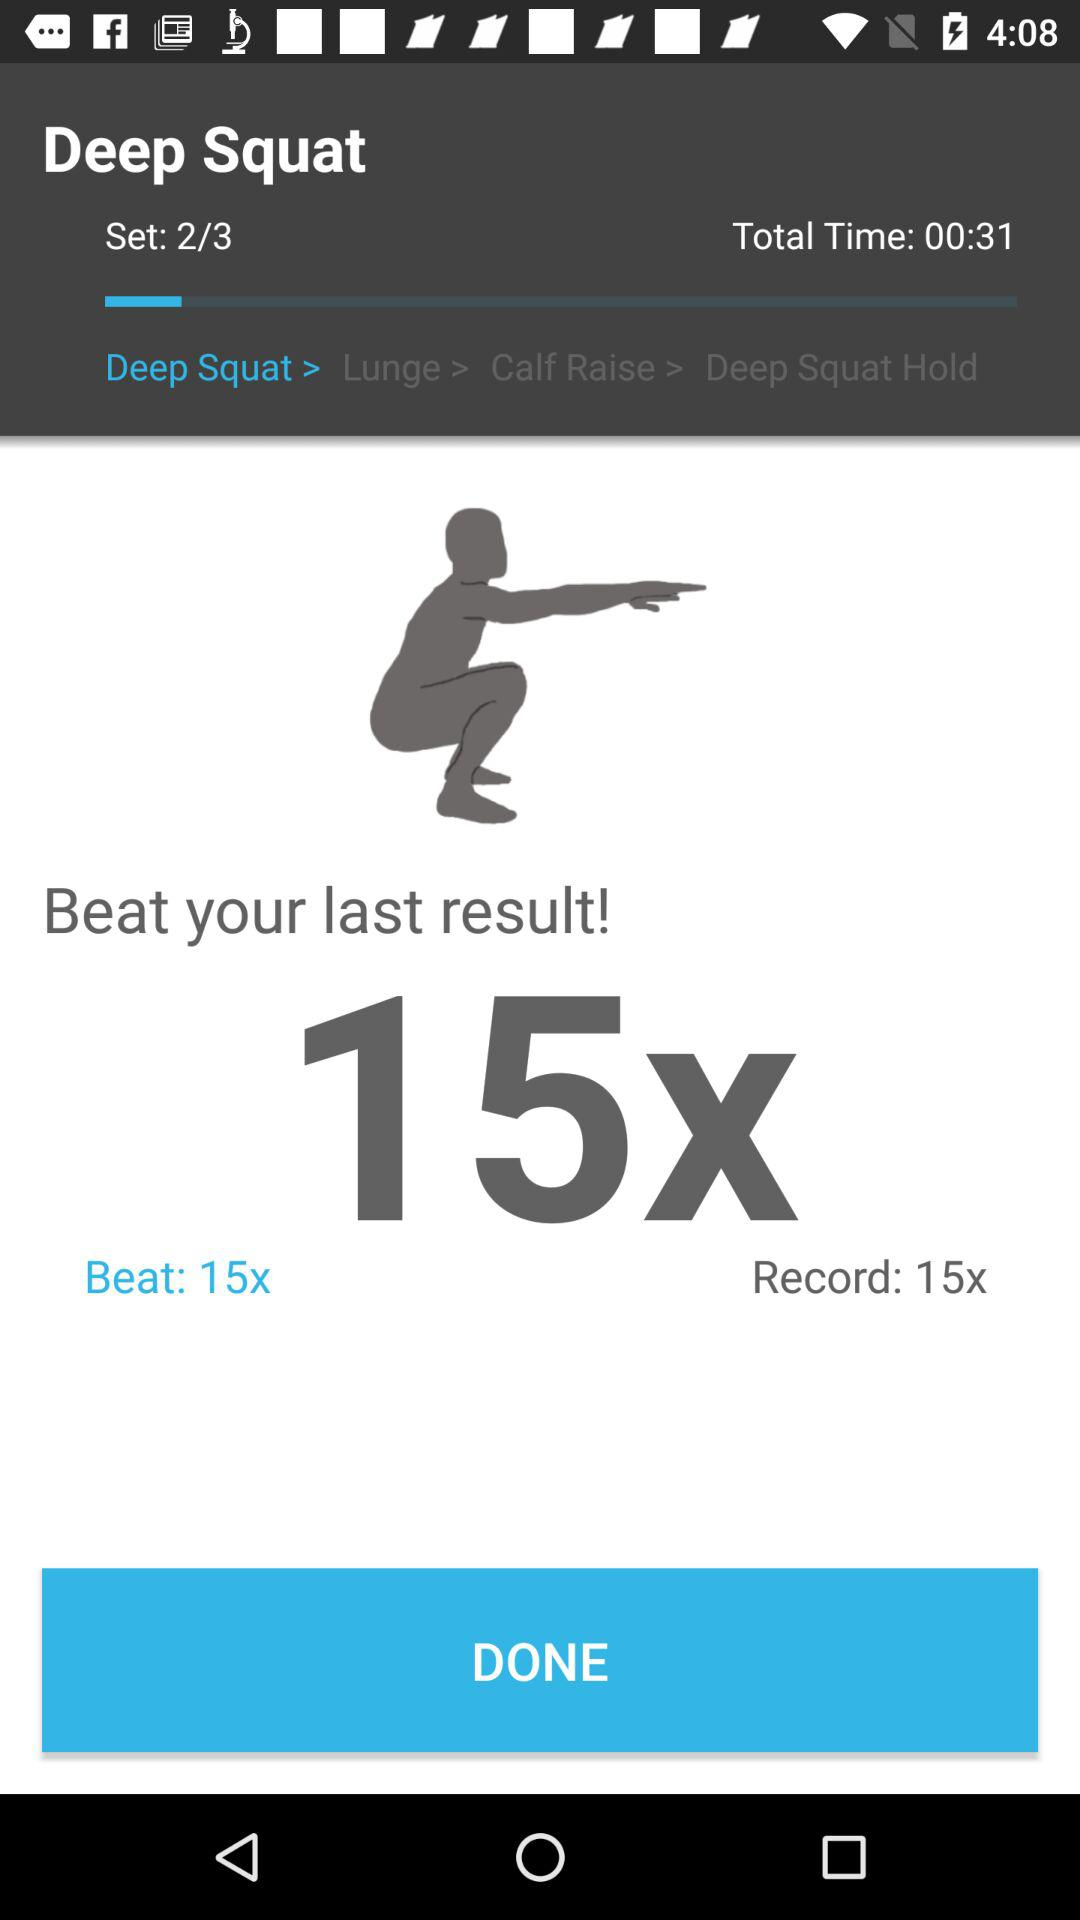What was the last result that could be beaten? The last result was 15 deep squats. 